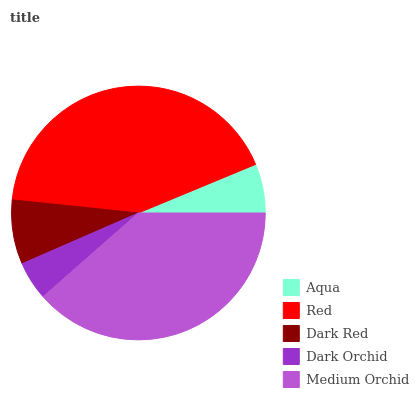Is Dark Orchid the minimum?
Answer yes or no. Yes. Is Red the maximum?
Answer yes or no. Yes. Is Dark Red the minimum?
Answer yes or no. No. Is Dark Red the maximum?
Answer yes or no. No. Is Red greater than Dark Red?
Answer yes or no. Yes. Is Dark Red less than Red?
Answer yes or no. Yes. Is Dark Red greater than Red?
Answer yes or no. No. Is Red less than Dark Red?
Answer yes or no. No. Is Dark Red the high median?
Answer yes or no. Yes. Is Dark Red the low median?
Answer yes or no. Yes. Is Medium Orchid the high median?
Answer yes or no. No. Is Aqua the low median?
Answer yes or no. No. 